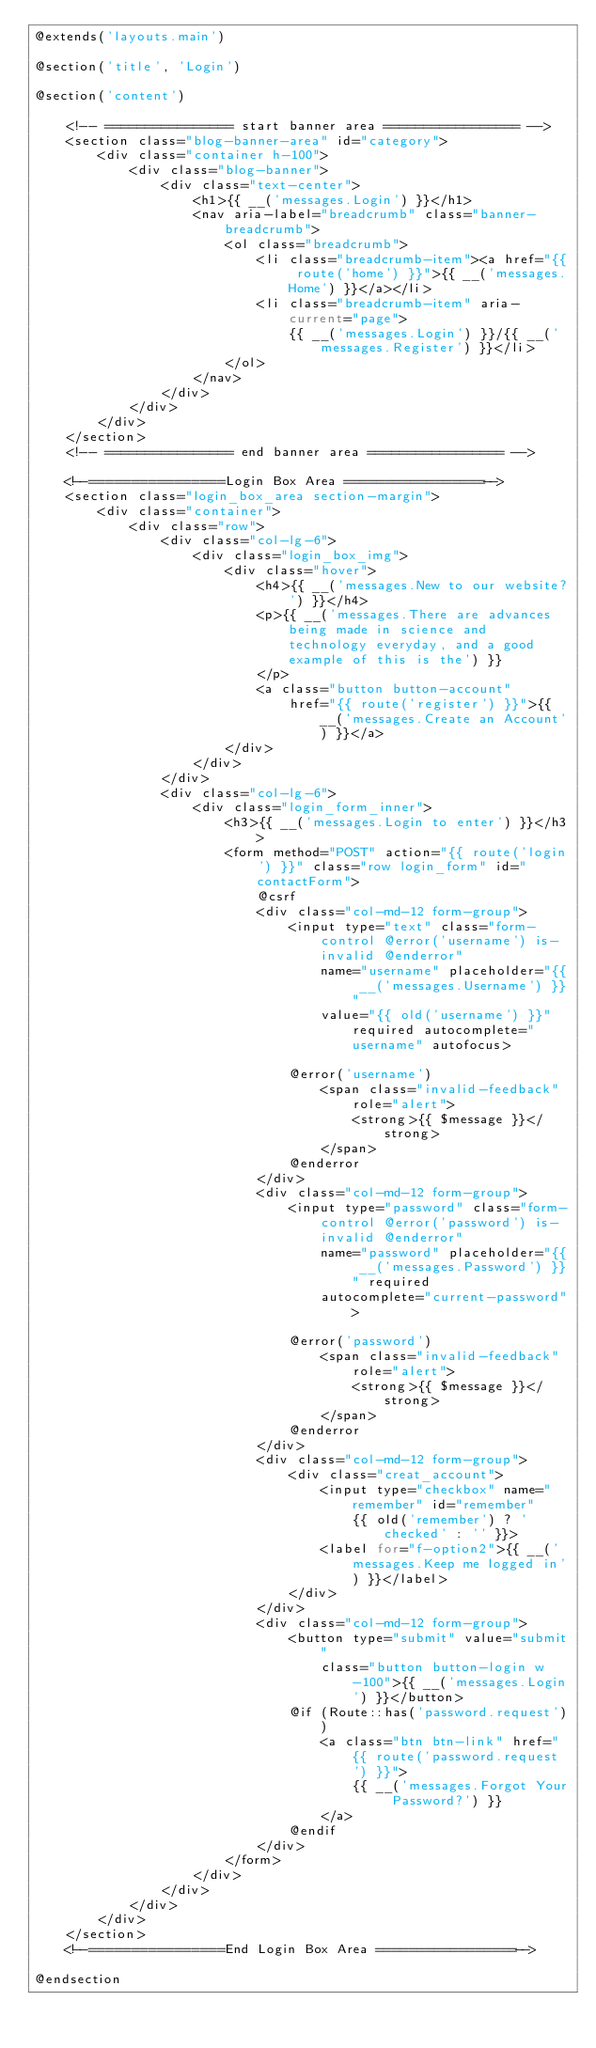Convert code to text. <code><loc_0><loc_0><loc_500><loc_500><_PHP_>@extends('layouts.main')

@section('title', 'Login')

@section('content')

    <!-- ================ start banner area ================= -->
    <section class="blog-banner-area" id="category">
        <div class="container h-100">
            <div class="blog-banner">
                <div class="text-center">
                    <h1>{{ __('messages.Login') }}</h1>
                    <nav aria-label="breadcrumb" class="banner-breadcrumb">
                        <ol class="breadcrumb">
                            <li class="breadcrumb-item"><a href="{{ route('home') }}">{{ __('messages.Home') }}</a></li>
                            <li class="breadcrumb-item" aria-current="page">
                                {{ __('messages.Login') }}/{{ __('messages.Register') }}</li>
                        </ol>
                    </nav>
                </div>
            </div>
        </div>
    </section>
    <!-- ================ end banner area ================= -->

    <!--================Login Box Area =================-->
    <section class="login_box_area section-margin">
        <div class="container">
            <div class="row">
                <div class="col-lg-6">
                    <div class="login_box_img">
                        <div class="hover">
                            <h4>{{ __('messages.New to our website?') }}</h4>
                            <p>{{ __('messages.There are advances being made in science and technology everyday, and a good example of this is the') }}
                            </p>
                            <a class="button button-account"
                                href="{{ route('register') }}">{{ __('messages.Create an Account') }}</a>
                        </div>
                    </div>
                </div>
                <div class="col-lg-6">
                    <div class="login_form_inner">
                        <h3>{{ __('messages.Login to enter') }}</h3>
                        <form method="POST" action="{{ route('login') }}" class="row login_form" id="contactForm">
                            @csrf
                            <div class="col-md-12 form-group">
                                <input type="text" class="form-control @error('username') is-invalid @enderror"
                                    name="username" placeholder="{{ __('messages.Username') }}"
                                    value="{{ old('username') }}" required autocomplete="username" autofocus>

                                @error('username')
                                    <span class="invalid-feedback" role="alert">
                                        <strong>{{ $message }}</strong>
                                    </span>
                                @enderror
                            </div>
                            <div class="col-md-12 form-group">
                                <input type="password" class="form-control @error('password') is-invalid @enderror"
                                    name="password" placeholder="{{ __('messages.Password') }}" required
                                    autocomplete="current-password">

                                @error('password')
                                    <span class="invalid-feedback" role="alert">
                                        <strong>{{ $message }}</strong>
                                    </span>
                                @enderror
                            </div>
                            <div class="col-md-12 form-group">
                                <div class="creat_account">
                                    <input type="checkbox" name="remember" id="remember"
                                        {{ old('remember') ? 'checked' : '' }}>
                                    <label for="f-option2">{{ __('messages.Keep me logged in') }}</label>
                                </div>
                            </div>
                            <div class="col-md-12 form-group">
                                <button type="submit" value="submit"
                                    class="button button-login w-100">{{ __('messages.Login') }}</button>
                                @if (Route::has('password.request'))
                                    <a class="btn btn-link" href="{{ route('password.request') }}">
                                        {{ __('messages.Forgot Your Password?') }}
                                    </a>
                                @endif
                            </div>
                        </form>
                    </div>
                </div>
            </div>
        </div>
    </section>
    <!--================End Login Box Area =================-->

@endsection
</code> 